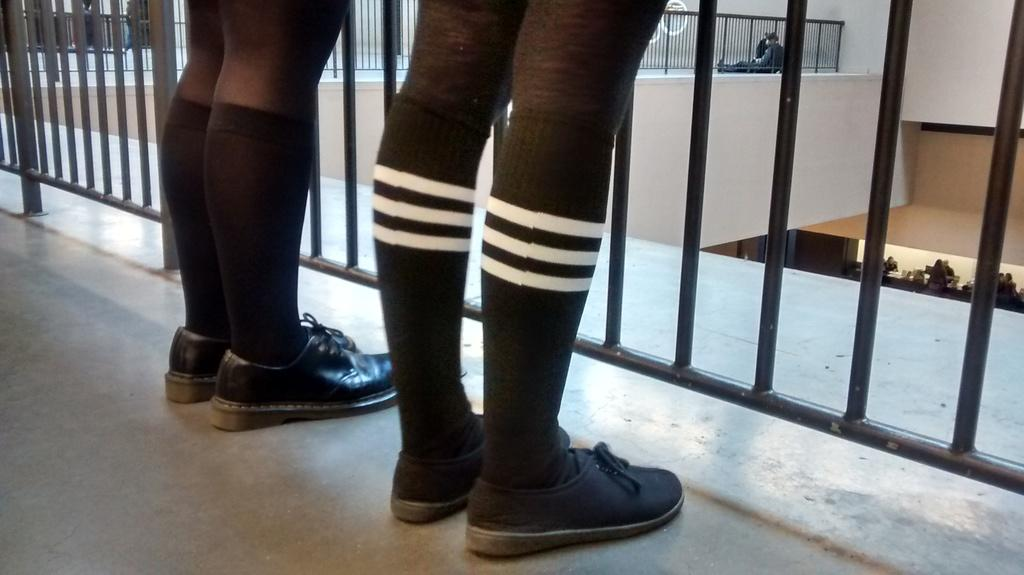How many people are standing on the floor in the image? There are two people standing on the floor in the image. Where are the two people located in relation to the railing? The people are near the railing in the image. What can be seen in the background of the image? In the background, there are railings, a wall, other people, and some objects. What type of frame is holding the corn in the image? There is no frame or corn present in the image. 